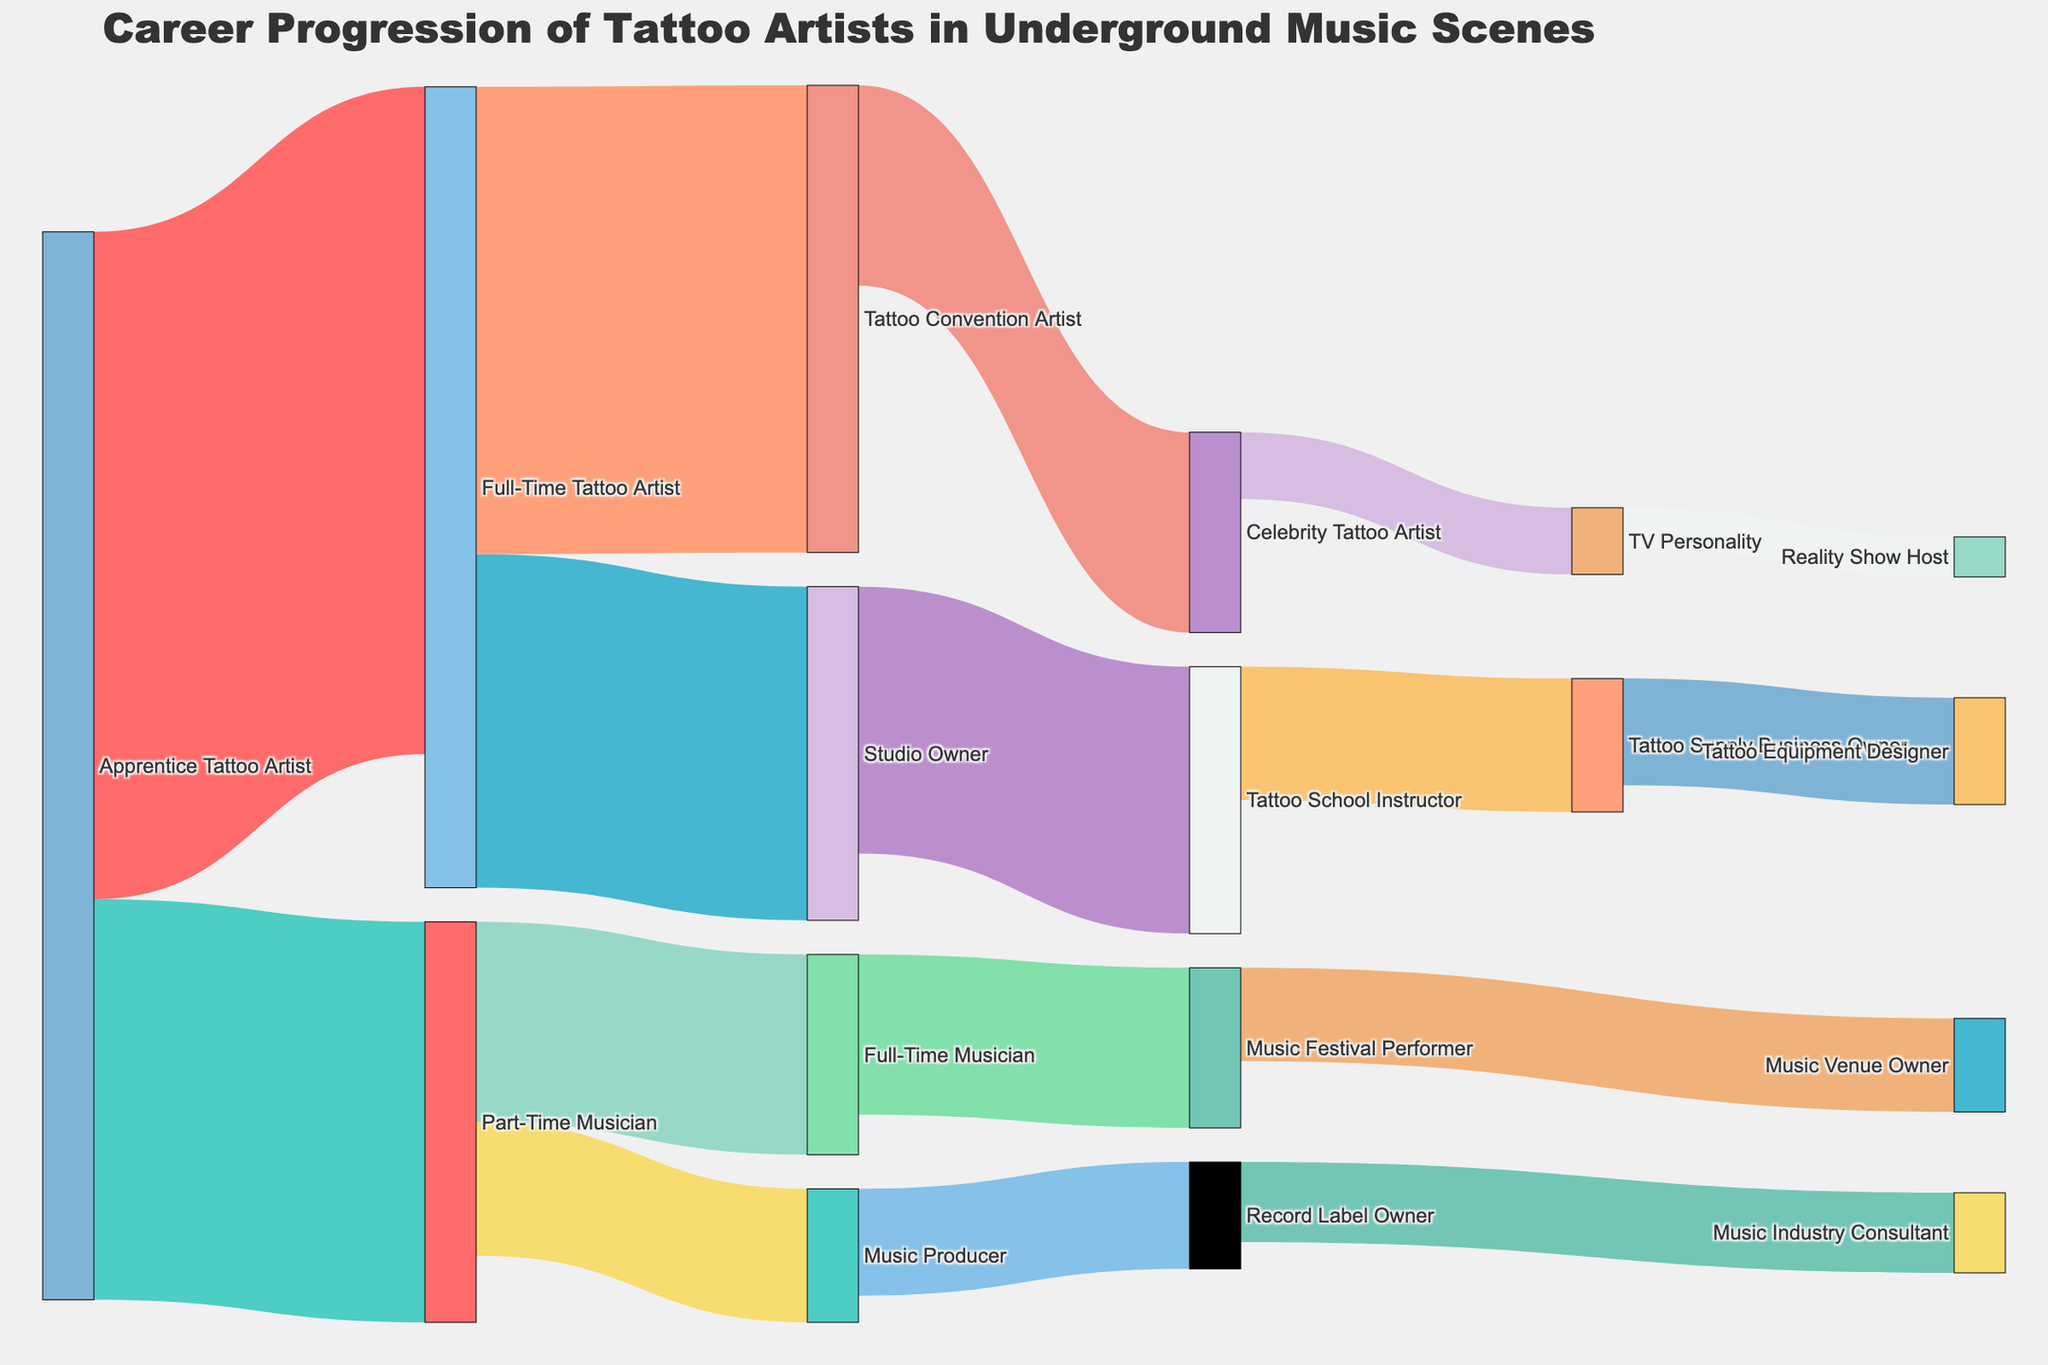What is the main title of the figure? The title is typically positioned at the top of the diagram. In this instance, it reads, "Career Progression of Tattoo Artists in Underground Music Scenes".
Answer: Career Progression of Tattoo Artists in Underground Music Scenes How many people progress from Apprentice Tattoo Artist to Full-Time Tattoo Artist? Look for the flow linking Apprentice Tattoo Artist to Full-Time Tattoo Artist and note the value displayed on the link, which is 50.
Answer: 50 Which career path transitions have the smallest number of people? Identify the flows by their values. The smallest values on the diagram are for transitions to TV Personality and Reality Show Host, with values of 3 and 5 respectively.
Answer: TV Personality and Reality Show Host How many individuals move from Part-Time Musician to Music Producer? Locate the link connecting Part-Time Musician to Music Producer and observe the value on the link, which is 10.
Answer: 10 What is the total number of people who remain within the tattoo artist industry after being Full-Time Tattoo Artists? Add the values of all connections originating from Full-Time Tattoo Artist that remain within the tattoo artist industry. These are to Studio Owner (25) and Tattoo Convention Artist (35), summing up to 60.
Answer: 60 Which career transitions have the highest value in the diagram? Determine which paths have the highest values. The transition with the largest value is the one from Apprentice Tattoo Artist to Full-Time Tattoo Artist, which stands at 50.
Answer: Apprentice Tattoo Artist to Full-Time Tattoo Artist How many total career transitions are represented in the diagram? Count the number of unique source-to-target transitions or links visible in the diagram. There are 16 different transitions presented.
Answer: 16 Compare the number of people who transition to Music Festival Performer from Full-Time Musician to those who transition to Music Industry Consultant from Record Label Owner. Which is higher? Identify the values on the respective links. Transitioning to Music Festival Performer from Full-Time Musician has a value of 12, while to Music Industry Consultant from Record Label Owner has a value of 6. 12 is greater than 6.
Answer: Music Festival Performer from Full-Time Musician What is the combined value of people who end up in the music scene from the beginning of being an Apprentice Tattoo Artist? Trace all paths from Apprentice Tattoo Artist to the music scene. Apprentice Tattoo Artist to Part-Time Musician (30), which further divides into Full-Time Musician (15) and Music Producer (10). Their sum is 30 + 15 + 10 = 55.
Answer: 55 What is the cumulative value of people who become involved with a business or ownership role in both tattoo and music careers? Add all values for paths leading to roles identified as business or ownership. Music Producer to Record Label Owner (8), Music Festival Performer to Music Venue Owner (7), and remaining values for tattoo-related roles: Studio Owner (25) to Tattoo School Instructor (20) and Tattoo Supply Business Owner (10). Their combined sum is 8 + 7 + 10 + 20 = 45.
Answer: 45 